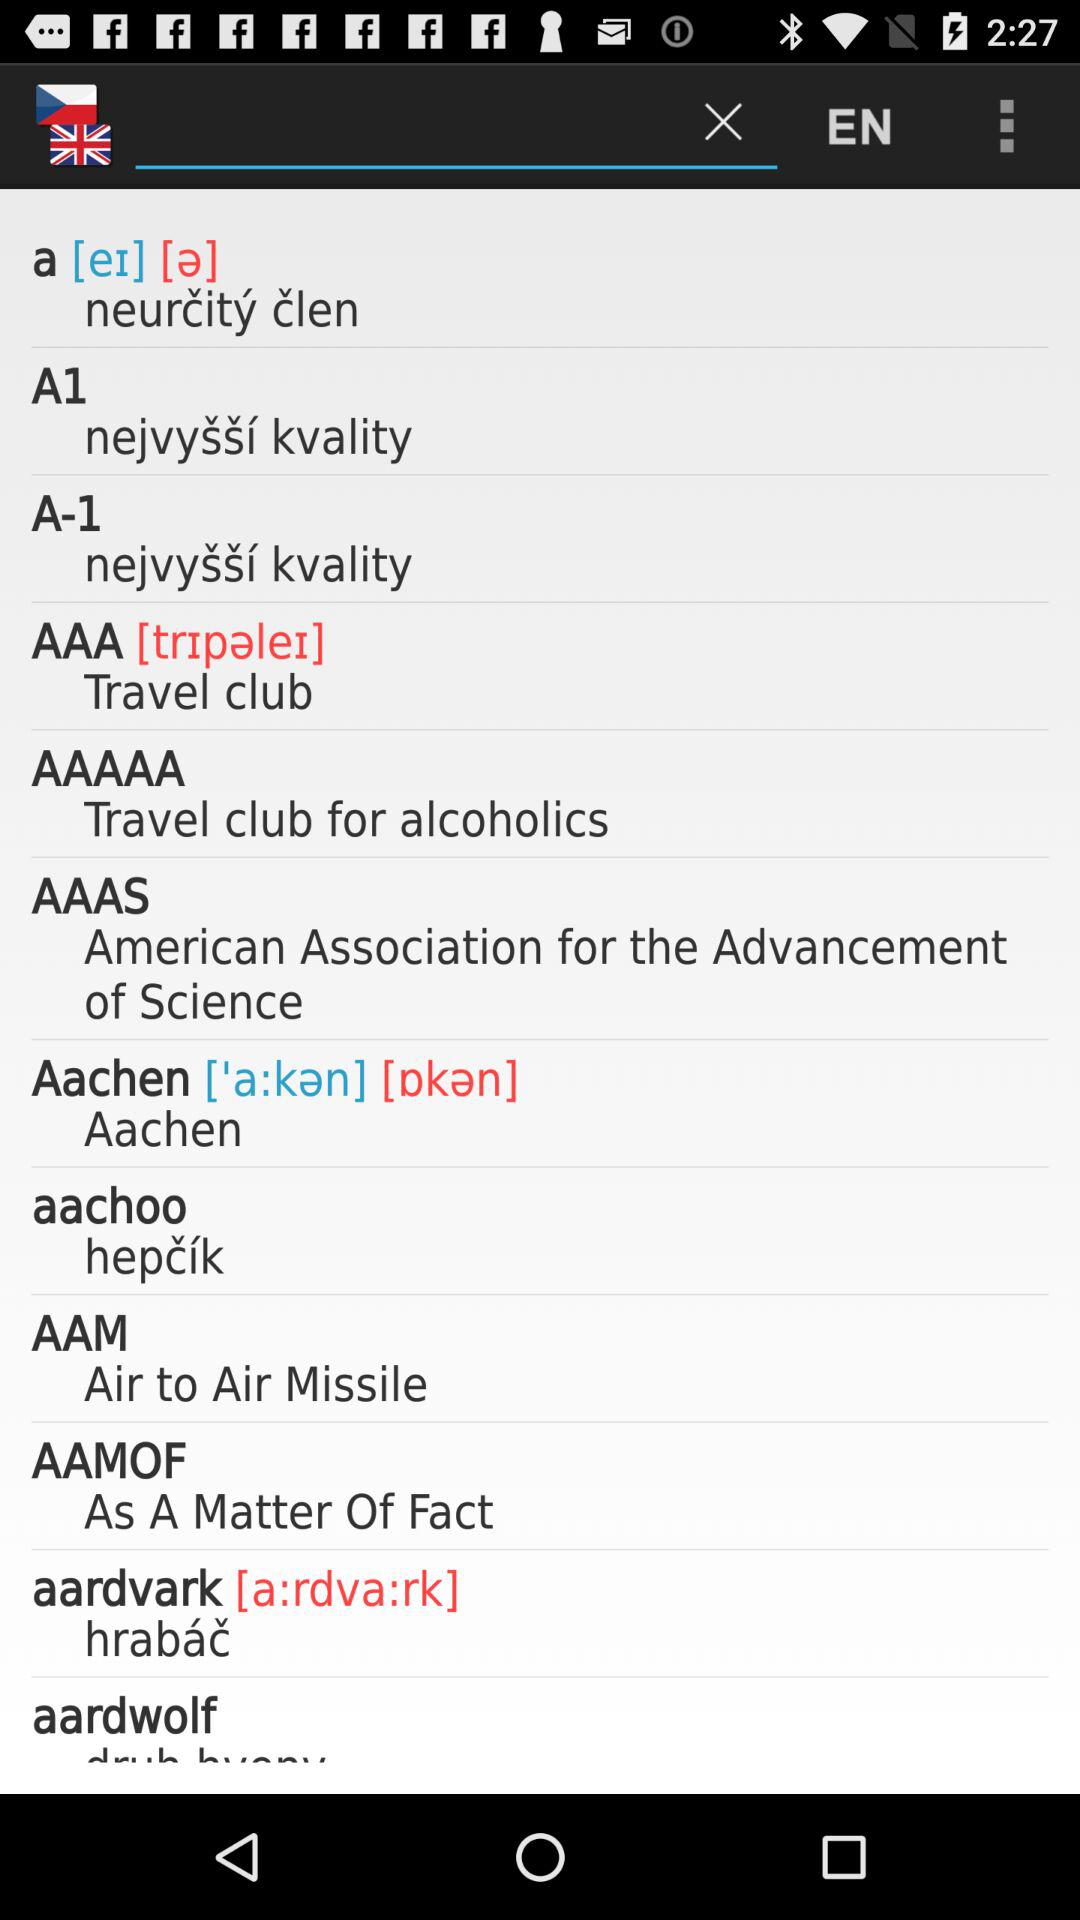What is the full form of AAAS? The full form of AAAS is "American Association for the Advancement of Science". 